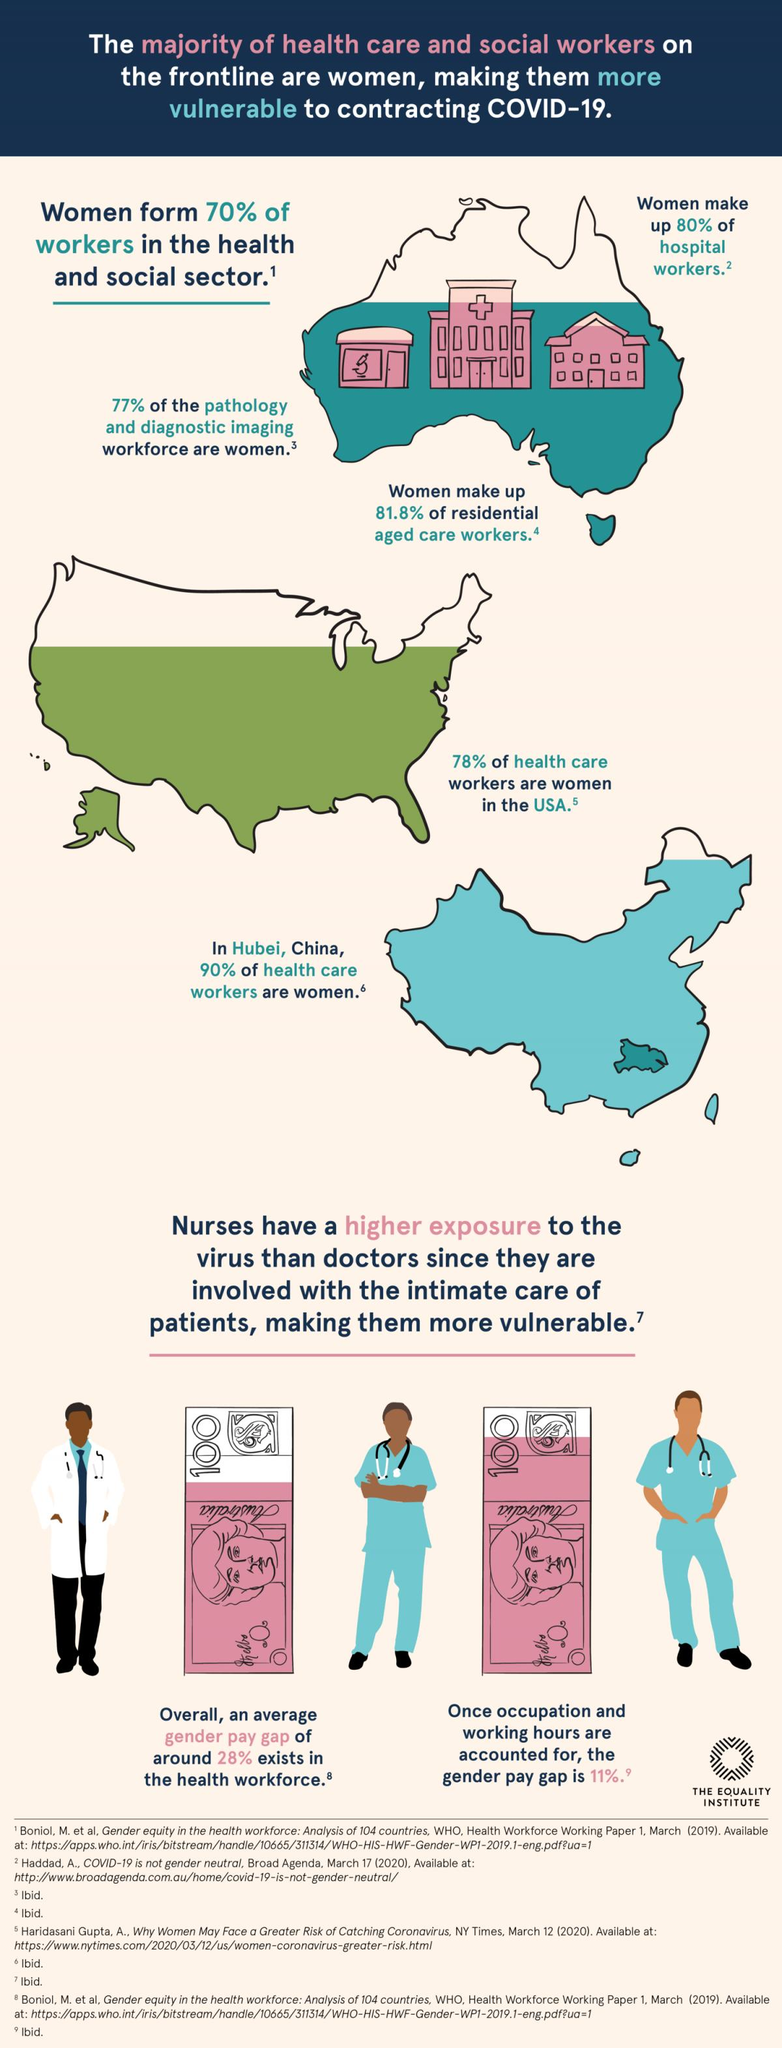Draw attention to some important aspects in this diagram. Approximately 20% of women do not work as hospital workers. According to the pathology and diagnostic imaging workforce, 23% of the workforce is made up of individuals who are not women. According to recent reports, approximately 10% of health care workers in Hubei are not women. According to a recent survey, 30% of workers in the health and social sector are not women. According to a recent study, only 72% of health care workers in the USA are women, while 28% are not. 